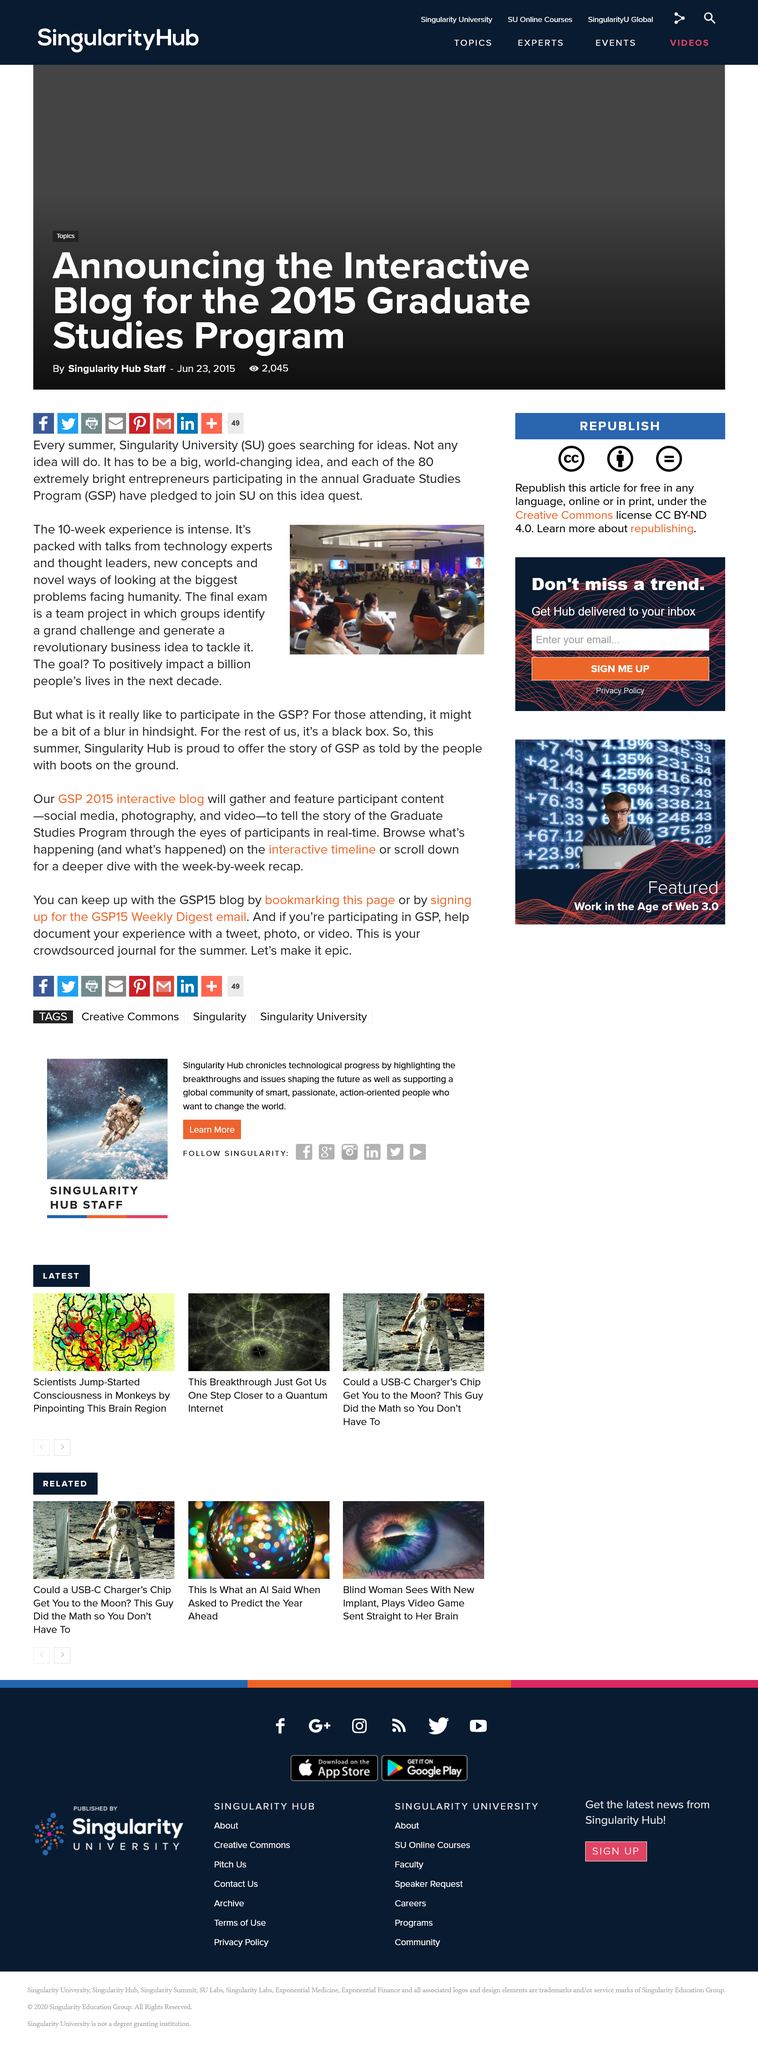Draw attention to some important aspects in this diagram. The experience is 10 weeks in duration. The chair in the picture is orange. Singularity University searches for ideas every summer. 